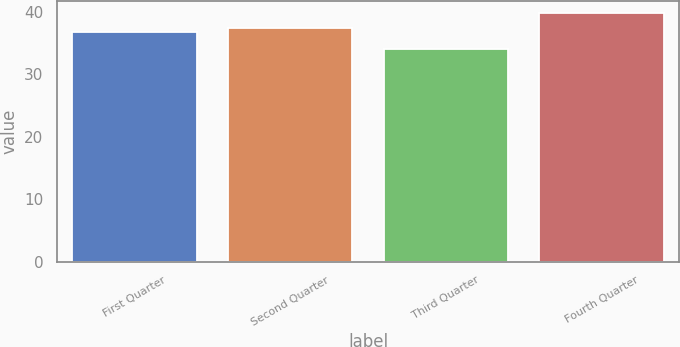Convert chart to OTSL. <chart><loc_0><loc_0><loc_500><loc_500><bar_chart><fcel>First Quarter<fcel>Second Quarter<fcel>Third Quarter<fcel>Fourth Quarter<nl><fcel>36.73<fcel>37.3<fcel>34.06<fcel>39.74<nl></chart> 